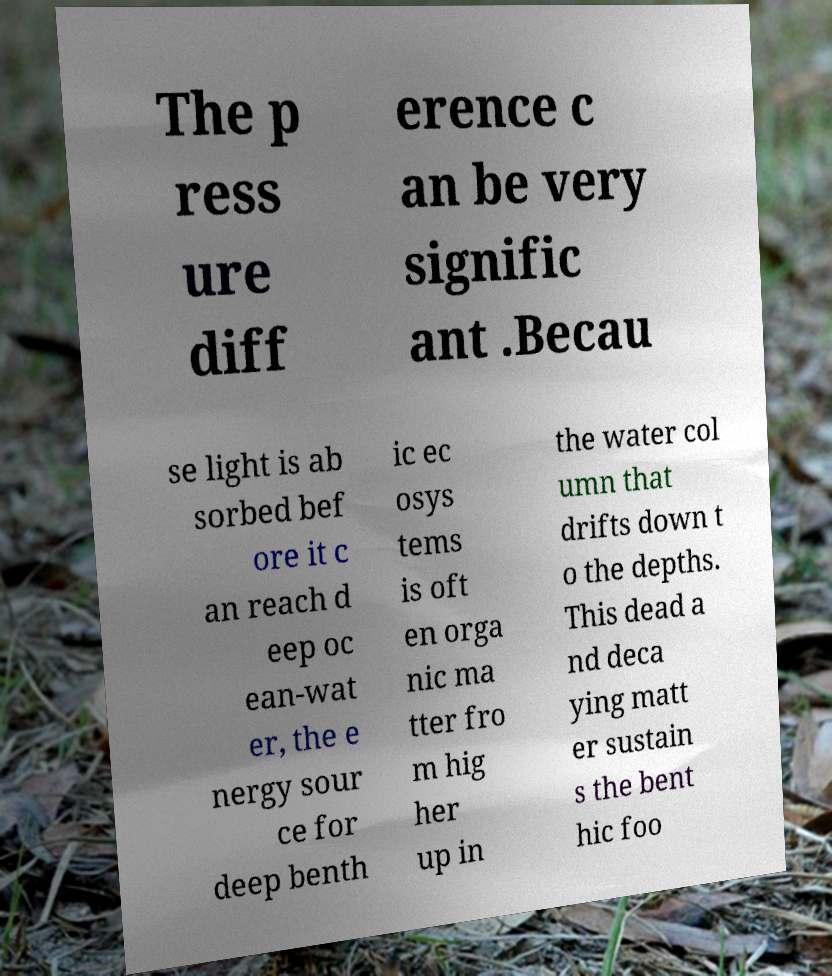Can you read and provide the text displayed in the image?This photo seems to have some interesting text. Can you extract and type it out for me? The p ress ure diff erence c an be very signific ant .Becau se light is ab sorbed bef ore it c an reach d eep oc ean-wat er, the e nergy sour ce for deep benth ic ec osys tems is oft en orga nic ma tter fro m hig her up in the water col umn that drifts down t o the depths. This dead a nd deca ying matt er sustain s the bent hic foo 